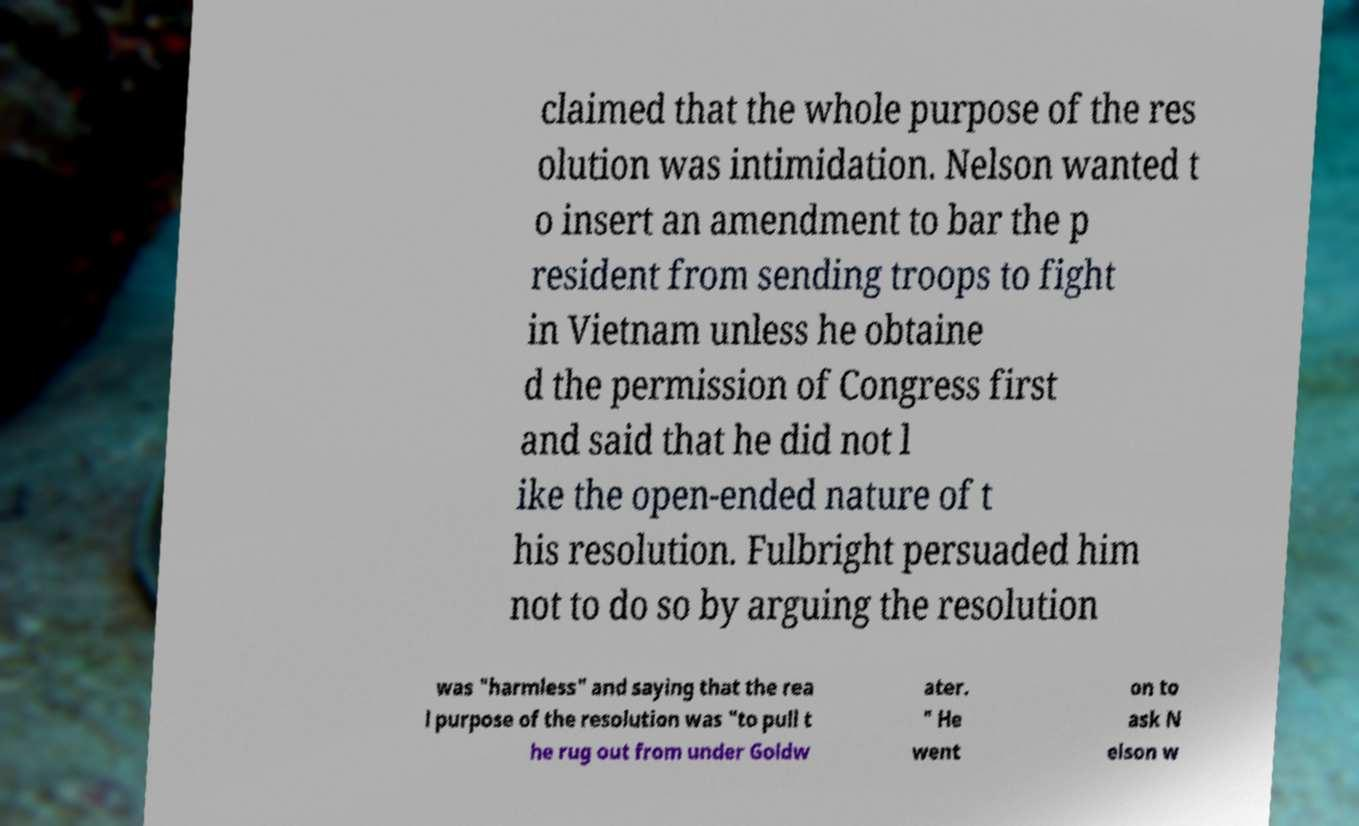Could you extract and type out the text from this image? claimed that the whole purpose of the res olution was intimidation. Nelson wanted t o insert an amendment to bar the p resident from sending troops to fight in Vietnam unless he obtaine d the permission of Congress first and said that he did not l ike the open-ended nature of t his resolution. Fulbright persuaded him not to do so by arguing the resolution was "harmless" and saying that the rea l purpose of the resolution was "to pull t he rug out from under Goldw ater. " He went on to ask N elson w 